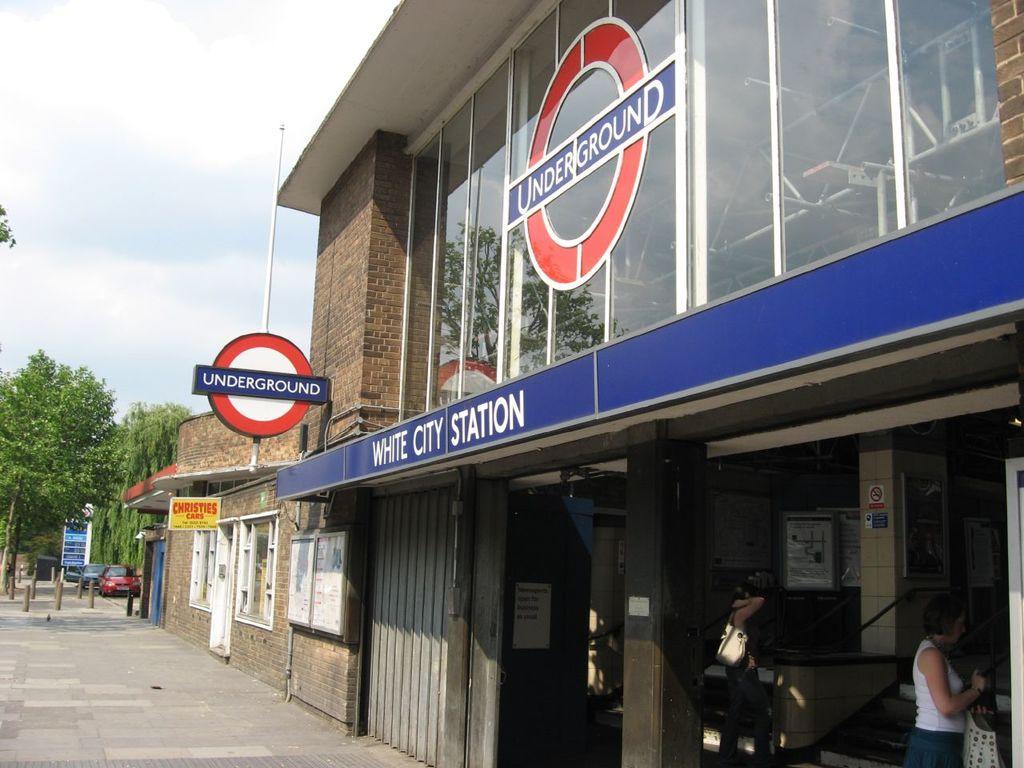Please provide a concise description of this image. In the foreground of this image, on the right, there are buildings, boards and a pole. In the background, there are trees, few bollards, vehicles, pavement, sky and the cloud. 